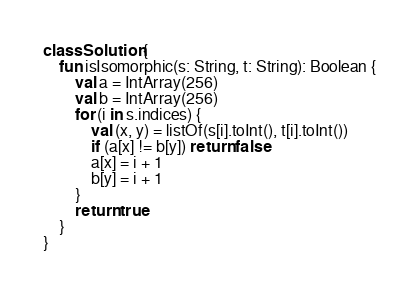<code> <loc_0><loc_0><loc_500><loc_500><_Kotlin_>class Solution {
    fun isIsomorphic(s: String, t: String): Boolean {
        val a = IntArray(256)
        val b = IntArray(256)
        for (i in s.indices) {
            val (x, y) = listOf(s[i].toInt(), t[i].toInt())
            if (a[x] != b[y]) return false
            a[x] = i + 1
            b[y] = i + 1
        }
        return true
    }
}</code> 